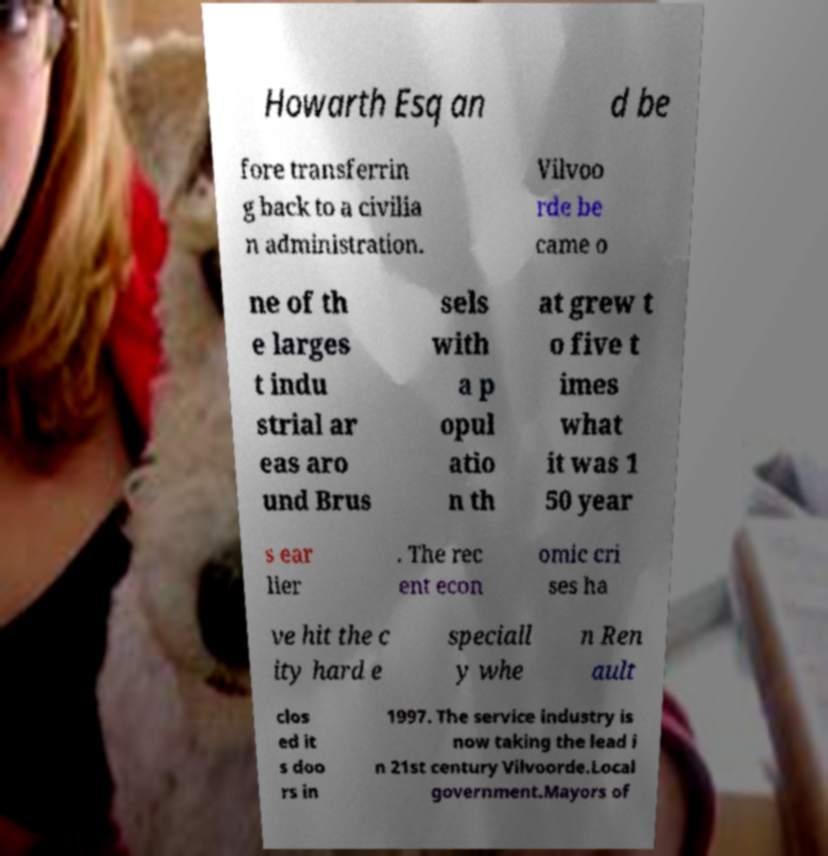Can you accurately transcribe the text from the provided image for me? Howarth Esq an d be fore transferrin g back to a civilia n administration. Vilvoo rde be came o ne of th e larges t indu strial ar eas aro und Brus sels with a p opul atio n th at grew t o five t imes what it was 1 50 year s ear lier . The rec ent econ omic cri ses ha ve hit the c ity hard e speciall y whe n Ren ault clos ed it s doo rs in 1997. The service industry is now taking the lead i n 21st century Vilvoorde.Local government.Mayors of 